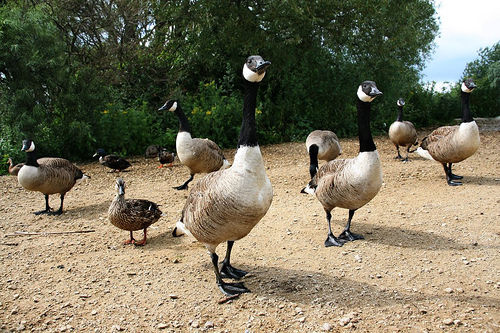<image>
Is the goose to the left of the goose? No. The goose is not to the left of the goose. From this viewpoint, they have a different horizontal relationship. Is the goose to the right of the tree? Yes. From this viewpoint, the goose is positioned to the right side relative to the tree. Is the tree next to the duck? No. The tree is not positioned next to the duck. They are located in different areas of the scene. Is the bird in front of the duck? Yes. The bird is positioned in front of the duck, appearing closer to the camera viewpoint. 